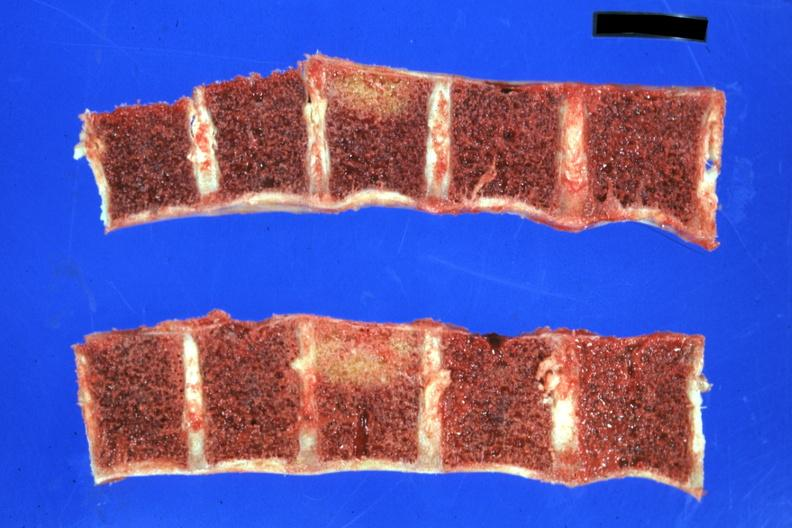what is present?
Answer the question using a single word or phrase. Joints 